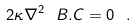Convert formula to latex. <formula><loc_0><loc_0><loc_500><loc_500>2 \kappa \nabla ^ { 2 } \ B . C = 0 \ .</formula> 